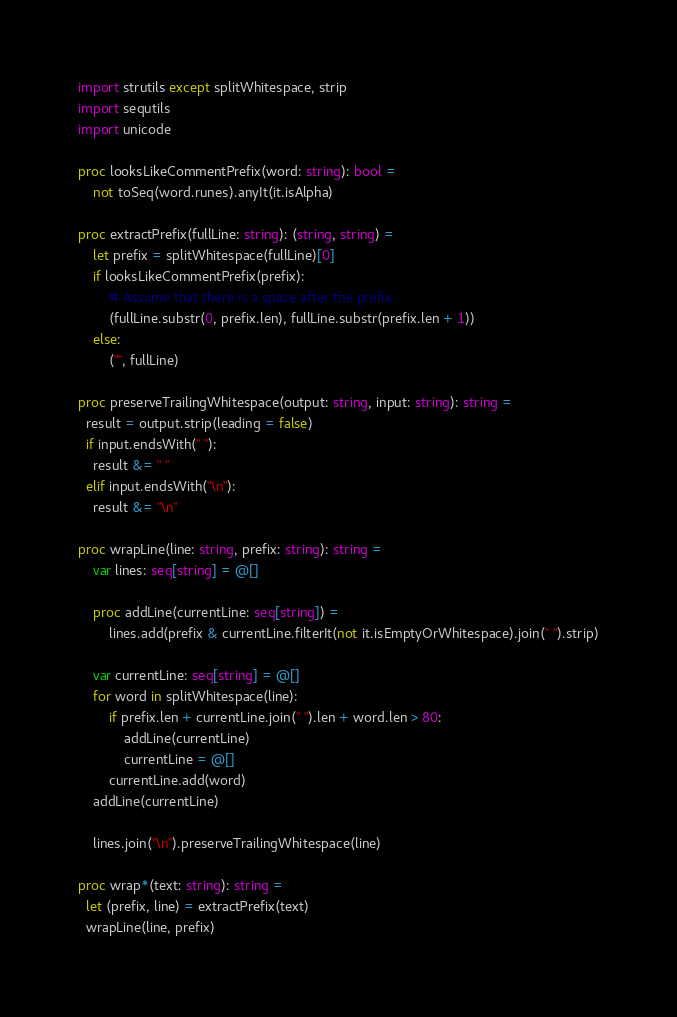<code> <loc_0><loc_0><loc_500><loc_500><_Nim_>import strutils except splitWhitespace, strip
import sequtils
import unicode

proc looksLikeCommentPrefix(word: string): bool =
    not toSeq(word.runes).anyIt(it.isAlpha)

proc extractPrefix(fullLine: string): (string, string) =
    let prefix = splitWhitespace(fullLine)[0]
    if looksLikeCommentPrefix(prefix):
        # Assume that there is a space after the prefix.
        (fullLine.substr(0, prefix.len), fullLine.substr(prefix.len + 1))
    else:
        ("", fullLine)

proc preserveTrailingWhitespace(output: string, input: string): string =
  result = output.strip(leading = false)
  if input.endsWith(" "):
    result &= " "
  elif input.endsWith("\n"):
    result &= "\n"

proc wrapLine(line: string, prefix: string): string =
    var lines: seq[string] = @[]

    proc addLine(currentLine: seq[string]) =
        lines.add(prefix & currentLine.filterIt(not it.isEmptyOrWhitespace).join(" ").strip)

    var currentLine: seq[string] = @[]
    for word in splitWhitespace(line):
        if prefix.len + currentLine.join(" ").len + word.len > 80:
            addLine(currentLine)
            currentLine = @[]
        currentLine.add(word)
    addLine(currentLine)

    lines.join("\n").preserveTrailingWhitespace(line)

proc wrap*(text: string): string =
  let (prefix, line) = extractPrefix(text)
  wrapLine(line, prefix)

</code> 